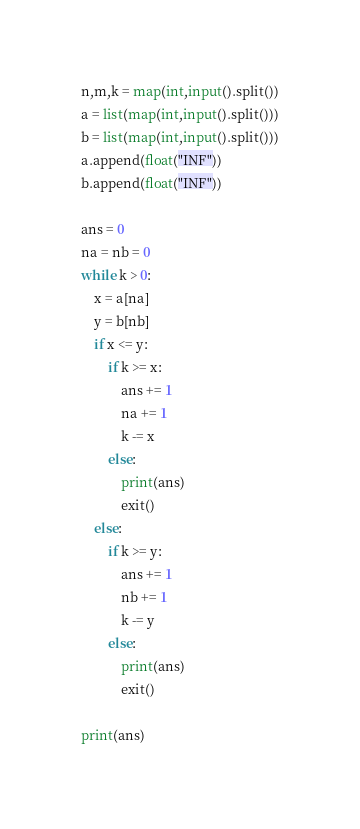<code> <loc_0><loc_0><loc_500><loc_500><_Python_>n,m,k = map(int,input().split())
a = list(map(int,input().split()))
b = list(map(int,input().split()))
a.append(float("INF"))
b.append(float("INF"))

ans = 0
na = nb = 0
while k > 0:
    x = a[na]
    y = b[nb]
    if x <= y:
        if k >= x:
            ans += 1
            na += 1
            k -= x
        else:
            print(ans)
            exit()
    else:
        if k >= y:
            ans += 1
            nb += 1
            k -= y
        else:
            print(ans)
            exit()
    
print(ans)</code> 